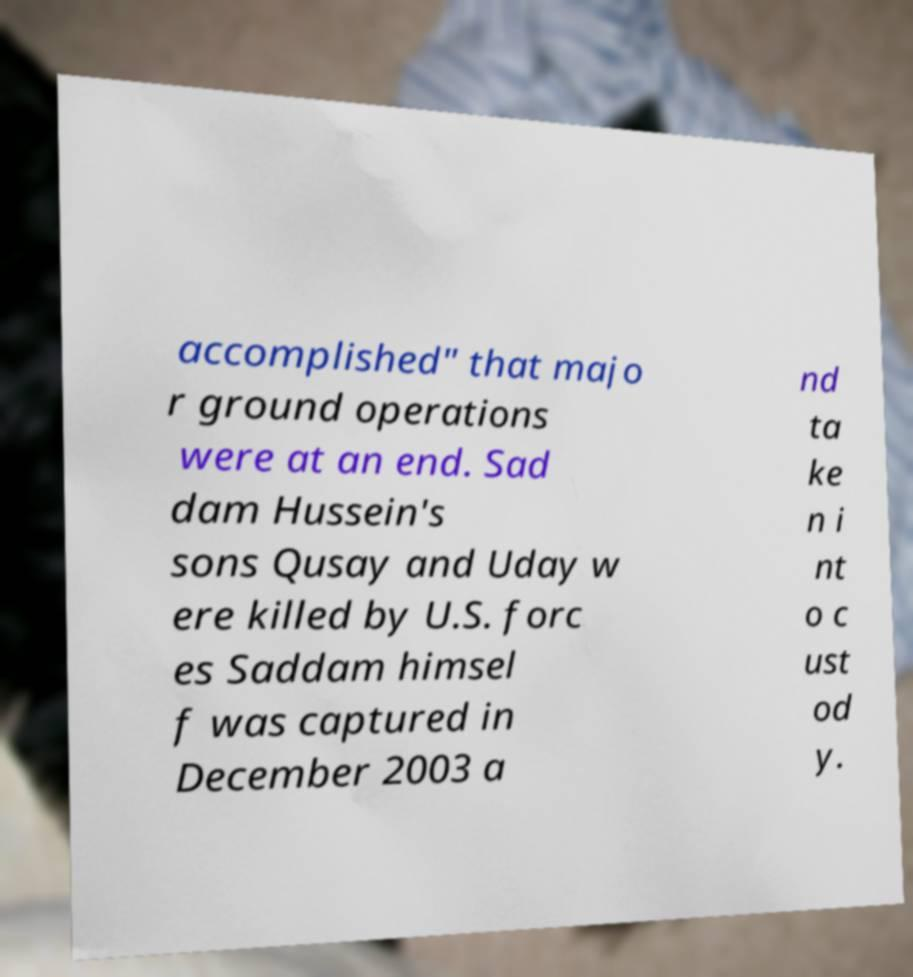Please identify and transcribe the text found in this image. accomplished" that majo r ground operations were at an end. Sad dam Hussein's sons Qusay and Uday w ere killed by U.S. forc es Saddam himsel f was captured in December 2003 a nd ta ke n i nt o c ust od y. 